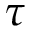Convert formula to latex. <formula><loc_0><loc_0><loc_500><loc_500>\tau</formula> 